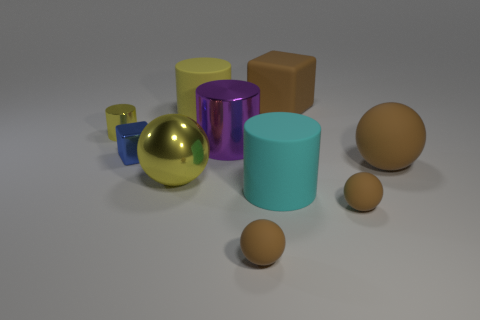Subtract all brown spheres. How many were subtracted if there are1brown spheres left? 2 Subtract all big yellow matte cylinders. How many cylinders are left? 3 Subtract 1 balls. How many balls are left? 3 Subtract all yellow balls. How many balls are left? 3 Subtract all red cylinders. How many brown balls are left? 3 Subtract all purple spheres. Subtract all purple blocks. How many spheres are left? 4 Subtract all big purple cylinders. Subtract all purple shiny cylinders. How many objects are left? 8 Add 9 large matte spheres. How many large matte spheres are left? 10 Add 5 large purple rubber balls. How many large purple rubber balls exist? 5 Subtract 0 cyan balls. How many objects are left? 10 